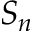<formula> <loc_0><loc_0><loc_500><loc_500>S _ { n }</formula> 